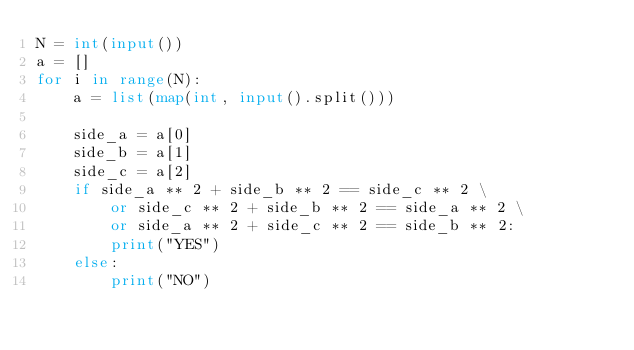Convert code to text. <code><loc_0><loc_0><loc_500><loc_500><_Python_>N = int(input())
a = []
for i in range(N):
    a = list(map(int, input().split()))
 
    side_a = a[0]
    side_b = a[1]
    side_c = a[2]
    if side_a ** 2 + side_b ** 2 == side_c ** 2 \
        or side_c ** 2 + side_b ** 2 == side_a ** 2 \
        or side_a ** 2 + side_c ** 2 == side_b ** 2:
        print("YES")
    else:
        print("NO")</code> 